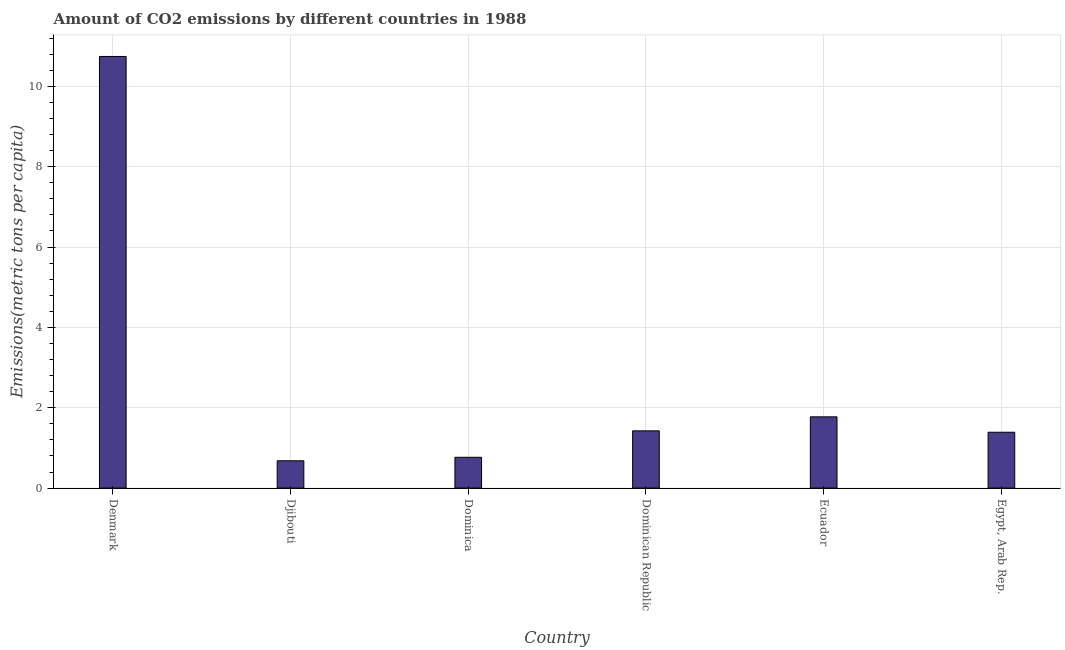Does the graph contain grids?
Offer a terse response. Yes. What is the title of the graph?
Keep it short and to the point. Amount of CO2 emissions by different countries in 1988. What is the label or title of the X-axis?
Keep it short and to the point. Country. What is the label or title of the Y-axis?
Give a very brief answer. Emissions(metric tons per capita). What is the amount of co2 emissions in Egypt, Arab Rep.?
Provide a succinct answer. 1.39. Across all countries, what is the maximum amount of co2 emissions?
Offer a very short reply. 10.74. Across all countries, what is the minimum amount of co2 emissions?
Provide a succinct answer. 0.68. In which country was the amount of co2 emissions minimum?
Your answer should be very brief. Djibouti. What is the sum of the amount of co2 emissions?
Provide a short and direct response. 16.78. What is the difference between the amount of co2 emissions in Denmark and Ecuador?
Your response must be concise. 8.97. What is the average amount of co2 emissions per country?
Make the answer very short. 2.8. What is the median amount of co2 emissions?
Your answer should be very brief. 1.41. In how many countries, is the amount of co2 emissions greater than 6.4 metric tons per capita?
Give a very brief answer. 1. What is the ratio of the amount of co2 emissions in Dominican Republic to that in Egypt, Arab Rep.?
Provide a succinct answer. 1.02. Is the amount of co2 emissions in Denmark less than that in Djibouti?
Your response must be concise. No. Is the difference between the amount of co2 emissions in Djibouti and Dominica greater than the difference between any two countries?
Keep it short and to the point. No. What is the difference between the highest and the second highest amount of co2 emissions?
Offer a very short reply. 8.97. Is the sum of the amount of co2 emissions in Denmark and Djibouti greater than the maximum amount of co2 emissions across all countries?
Your answer should be very brief. Yes. What is the difference between the highest and the lowest amount of co2 emissions?
Offer a terse response. 10.06. Are all the bars in the graph horizontal?
Provide a succinct answer. No. What is the Emissions(metric tons per capita) of Denmark?
Your response must be concise. 10.74. What is the Emissions(metric tons per capita) of Djibouti?
Ensure brevity in your answer.  0.68. What is the Emissions(metric tons per capita) in Dominica?
Make the answer very short. 0.77. What is the Emissions(metric tons per capita) in Dominican Republic?
Offer a very short reply. 1.42. What is the Emissions(metric tons per capita) in Ecuador?
Offer a terse response. 1.77. What is the Emissions(metric tons per capita) of Egypt, Arab Rep.?
Offer a very short reply. 1.39. What is the difference between the Emissions(metric tons per capita) in Denmark and Djibouti?
Give a very brief answer. 10.06. What is the difference between the Emissions(metric tons per capita) in Denmark and Dominica?
Offer a terse response. 9.98. What is the difference between the Emissions(metric tons per capita) in Denmark and Dominican Republic?
Offer a terse response. 9.32. What is the difference between the Emissions(metric tons per capita) in Denmark and Ecuador?
Provide a short and direct response. 8.97. What is the difference between the Emissions(metric tons per capita) in Denmark and Egypt, Arab Rep.?
Provide a succinct answer. 9.35. What is the difference between the Emissions(metric tons per capita) in Djibouti and Dominica?
Provide a succinct answer. -0.09. What is the difference between the Emissions(metric tons per capita) in Djibouti and Dominican Republic?
Keep it short and to the point. -0.74. What is the difference between the Emissions(metric tons per capita) in Djibouti and Ecuador?
Your answer should be very brief. -1.09. What is the difference between the Emissions(metric tons per capita) in Djibouti and Egypt, Arab Rep.?
Provide a short and direct response. -0.71. What is the difference between the Emissions(metric tons per capita) in Dominica and Dominican Republic?
Your answer should be compact. -0.66. What is the difference between the Emissions(metric tons per capita) in Dominica and Ecuador?
Your answer should be compact. -1.01. What is the difference between the Emissions(metric tons per capita) in Dominica and Egypt, Arab Rep.?
Your response must be concise. -0.62. What is the difference between the Emissions(metric tons per capita) in Dominican Republic and Ecuador?
Offer a terse response. -0.35. What is the difference between the Emissions(metric tons per capita) in Dominican Republic and Egypt, Arab Rep.?
Ensure brevity in your answer.  0.03. What is the difference between the Emissions(metric tons per capita) in Ecuador and Egypt, Arab Rep.?
Provide a short and direct response. 0.38. What is the ratio of the Emissions(metric tons per capita) in Denmark to that in Djibouti?
Offer a very short reply. 15.8. What is the ratio of the Emissions(metric tons per capita) in Denmark to that in Dominica?
Ensure brevity in your answer.  14.01. What is the ratio of the Emissions(metric tons per capita) in Denmark to that in Dominican Republic?
Your answer should be compact. 7.54. What is the ratio of the Emissions(metric tons per capita) in Denmark to that in Ecuador?
Provide a succinct answer. 6.06. What is the ratio of the Emissions(metric tons per capita) in Denmark to that in Egypt, Arab Rep.?
Keep it short and to the point. 7.73. What is the ratio of the Emissions(metric tons per capita) in Djibouti to that in Dominica?
Your response must be concise. 0.89. What is the ratio of the Emissions(metric tons per capita) in Djibouti to that in Dominican Republic?
Offer a very short reply. 0.48. What is the ratio of the Emissions(metric tons per capita) in Djibouti to that in Ecuador?
Provide a short and direct response. 0.38. What is the ratio of the Emissions(metric tons per capita) in Djibouti to that in Egypt, Arab Rep.?
Offer a terse response. 0.49. What is the ratio of the Emissions(metric tons per capita) in Dominica to that in Dominican Republic?
Keep it short and to the point. 0.54. What is the ratio of the Emissions(metric tons per capita) in Dominica to that in Ecuador?
Offer a terse response. 0.43. What is the ratio of the Emissions(metric tons per capita) in Dominica to that in Egypt, Arab Rep.?
Give a very brief answer. 0.55. What is the ratio of the Emissions(metric tons per capita) in Dominican Republic to that in Ecuador?
Give a very brief answer. 0.8. What is the ratio of the Emissions(metric tons per capita) in Dominican Republic to that in Egypt, Arab Rep.?
Your response must be concise. 1.02. What is the ratio of the Emissions(metric tons per capita) in Ecuador to that in Egypt, Arab Rep.?
Offer a terse response. 1.28. 